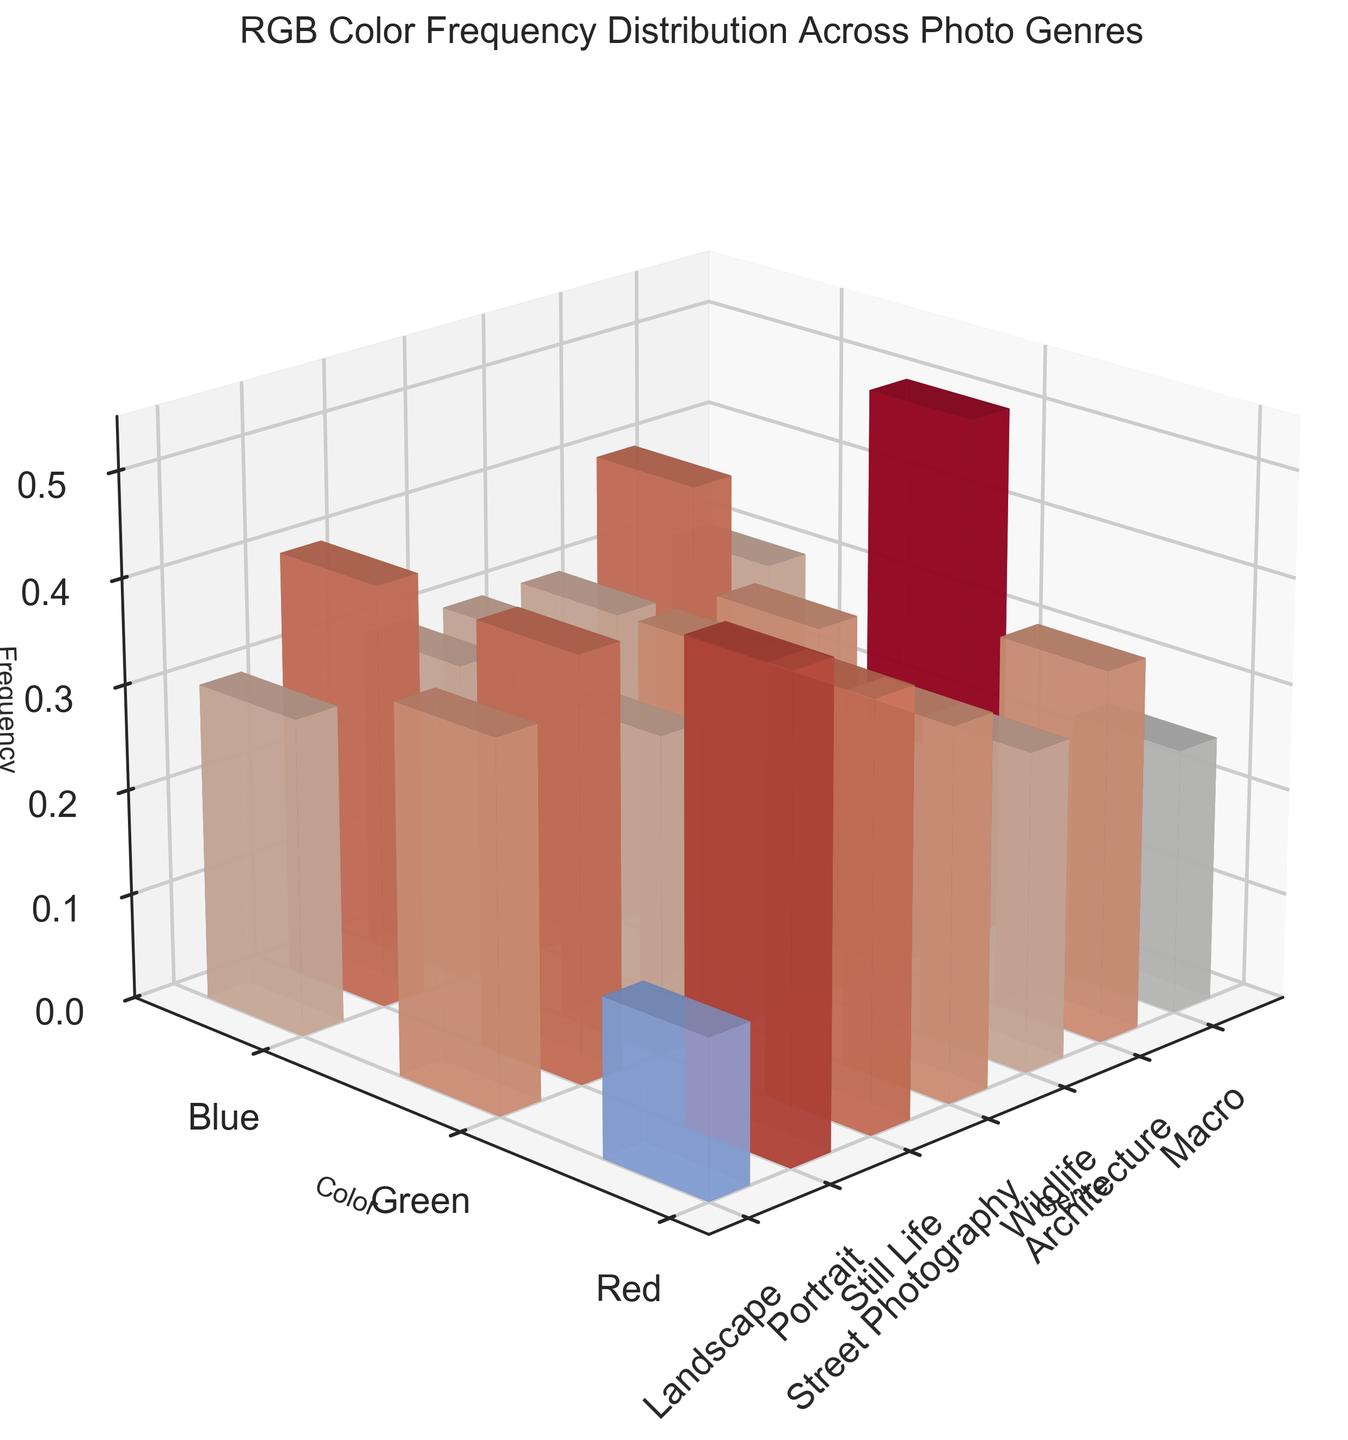What is the title of the plot? The title is usually at the top of the plot and represents the main subject. Here, the title is directly readable from the figure.
Answer: RGB Color Frequency Distribution Across Photo Genres Which genre has the highest red color frequency? By examining the height of the bars corresponding to the red color for each genre, the tallest bar represents the highest frequency. Here, the 'Architecture' genre has the highest red color frequency.
Answer: Architecture How many genres are displayed on the plot? The x-axis labels the genres. Counting these labels gives us the total number of genres in the plot. There are 8 genres: Landscape, Portrait, Still Life, Street Photography, Wildlife, Architecture, Macro, and one more not shown in the initial data snippet.
Answer: 8 Which color frequency is highest in the Landscape genre? Look at the different color bars (red, green, blue) for the Landscape label on the x-axis and compare their heights. The green bar is the tallest.
Answer: Green How does the blue color frequency in Portrait compare to that in Street Photography? Compare the heights of the blue bars for the Portrait and Street Photography genres. Both bars are of the same height, indicating equal frequency.
Answer: Equal What is the average green color frequency across all genres? Sum the green color frequencies for all genres and divide by the number of genres (8). The sum is 0.45 + 0.30 + 0.35 + 0.35 + 0.50 + 0.30 + 0.40 = 2.65. The average is 2.65 / 8.
Answer: 0.33125 Which genre has the lowest blue color frequency? Compare the heights of the blue bars across all genres. The genre with the shortest bar represents the lowest frequency. The 'Wildlife' genre has the lowest blue color frequency.
Answer: Wildlife Is there any genre where the color frequencies are all equal? Check the bars for each genre to see if the heights of red, green, and blue bars are identical. No genre has all color frequencies equal.
Answer: No Which color has the most diverse frequency distribution across genres? Observe the range of heights for each color bar across all genres. Green shows the most diversity from genre to genre.
Answer: Green How does the frequency of red color in Macro genre compare to that in Wildlife? Compare the heights of the red bars for both the Macro and Wildlife genres. The red bar for Macro is taller than that for Wildlife.
Answer: Higher in Macro 